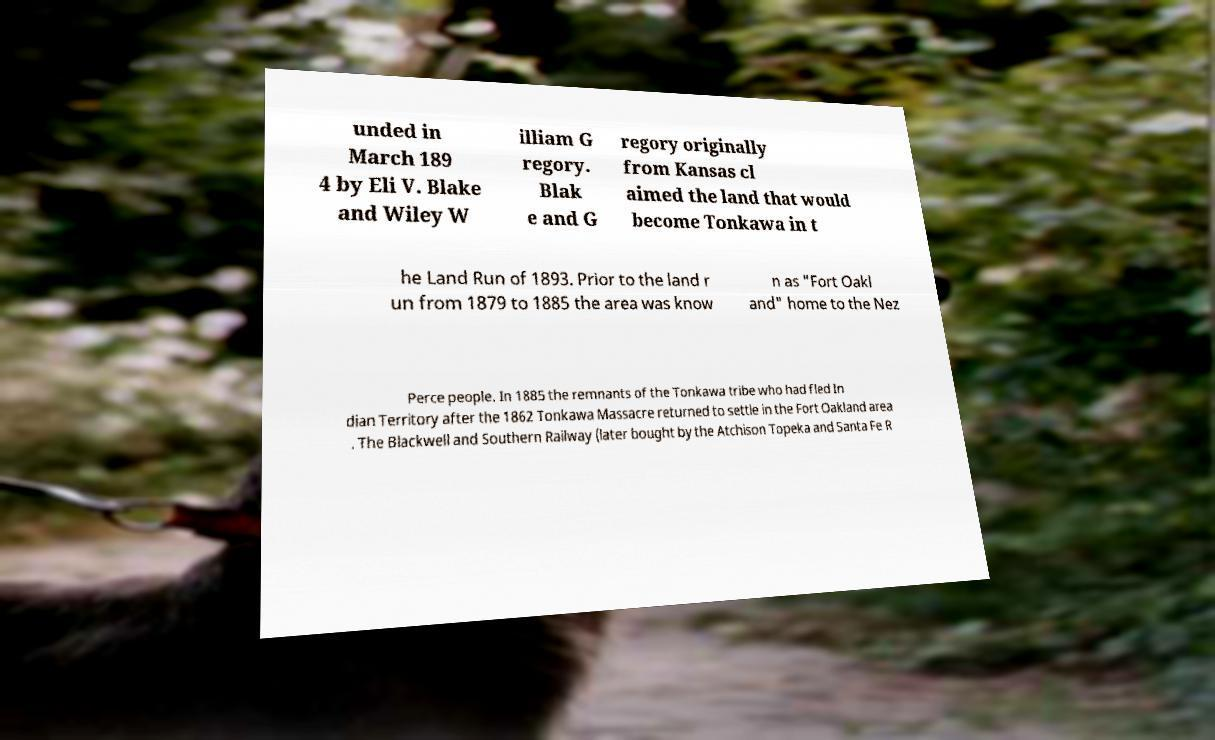Can you read and provide the text displayed in the image?This photo seems to have some interesting text. Can you extract and type it out for me? unded in March 189 4 by Eli V. Blake and Wiley W illiam G regory. Blak e and G regory originally from Kansas cl aimed the land that would become Tonkawa in t he Land Run of 1893. Prior to the land r un from 1879 to 1885 the area was know n as "Fort Oakl and" home to the Nez Perce people. In 1885 the remnants of the Tonkawa tribe who had fled In dian Territory after the 1862 Tonkawa Massacre returned to settle in the Fort Oakland area . The Blackwell and Southern Railway (later bought by the Atchison Topeka and Santa Fe R 